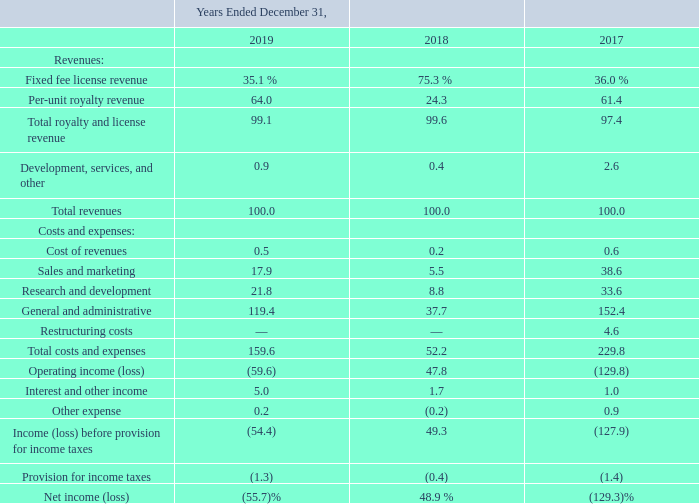Overview of 2019
Total revenues for 2019 were $36.0 million, a decrease of $75.0 million, or 68%, versus 2018. The decrease was primarily driven by the $70.9 million decrease in fixed fee license revenue and the $4.0 million decrease in per-unit royalty revenue.
For 2019, we had a net loss of $20.0 million as compared to $54.3 million of net income for 2018. The $74.4 million decrease in net income was mainly related to the $75.0 million decrease in total revenue partially offset by a $0.5 million decrease in cost and operating expenses for 2019 compared to 2018.
We adopted ASC 606, effective January 1, 2018. Consistent with the modified retrospective transaction method, our results of operations for periods prior to the adoption of ASC 606 remain unchanged. As a result, the change in total revenues from 2018 to 2019 included a component of accounting policy change arising from the adoption of ASC 606.
The following table sets forth our consolidated statements of income data as a percentage of total revenues:
Why was there a decrease in total revenues in 2019? Driven by the $70.9 million decrease in fixed fee license revenue and the $4.0 million decrease in per-unit royalty revenue. What was the decrease in total revenues from 2018 to 2019? $75.0 million. What led to $74.4 million decrease in net income? The $75.0 million decrease in total revenue partially offset by a $0.5 million decrease in cost and operating expenses for 2019 compared to 2018. What is the change in Fixed fee license revenue from 2018 and 2019?
Answer scale should be: percent. 35.1-75.3
Answer: -40.2. What is the change in Per-unit royalty revenue between 2018 and 2019?
Answer scale should be: percent. 64.0-24.3
Answer: 39.7. What is the average Fixed fee license revenue for 2018 and 2019?
Answer scale should be: percent. (35.1+75.3) / 2
Answer: 55.2. 